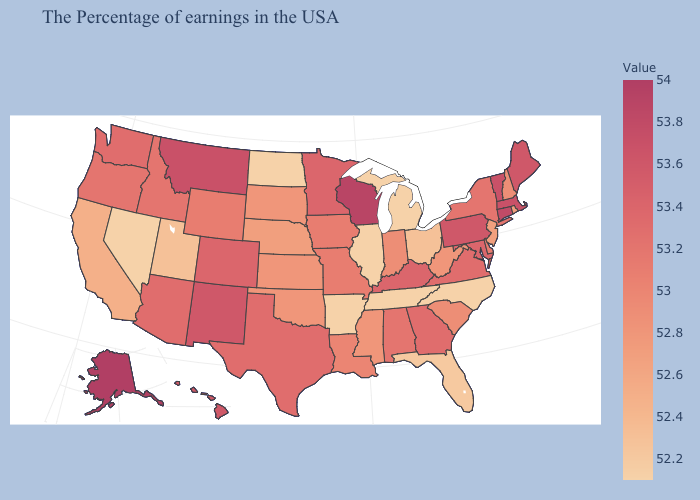Which states have the lowest value in the Northeast?
Write a very short answer. Rhode Island, New Jersey. Does Texas have a higher value than North Dakota?
Be succinct. Yes. Which states hav the highest value in the West?
Short answer required. Alaska. Does Vermont have a lower value than Indiana?
Keep it brief. No. Does Oregon have the lowest value in the USA?
Quick response, please. No. Does Maryland have the lowest value in the USA?
Give a very brief answer. No. Does Nevada have the lowest value in the West?
Quick response, please. Yes. Among the states that border Connecticut , does Massachusetts have the highest value?
Answer briefly. Yes. 